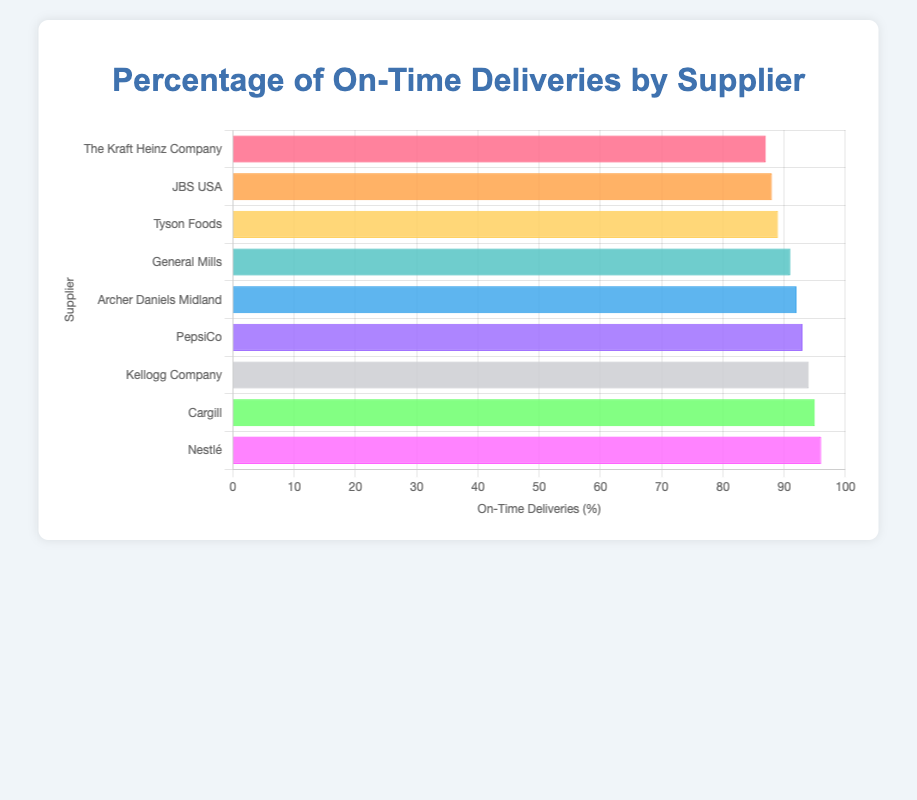What is the percentage of on-time deliveries for the supplier with the best performance? The supplier with the best performance is the one with the highest bar in the chart, which is Nestlé. The percentage of on-time deliveries for Nestlé is shown as 96%.
Answer: 96% Which supplier has the lowest percentage of on-time deliveries? To find the supplier with the lowest percentage of on-time deliveries, look for the shortest bar in the chart. The chart shows that The Kraft Heinz Company has the shortest bar, corresponding to 87%.
Answer: The Kraft Heinz Company What's the difference between the best and worst performers in on-time deliveries? The best performer is Nestlé with 96%, and the worst performer is The Kraft Heinz Company with 87%. The difference between them is 96% - 87% = 9%.
Answer: 9% Are there any suppliers with on-time delivery percentages that are the same? By examining the chart, you can see that each supplier has a distinct percentage of on-time deliveries, with no two suppliers sharing the same value.
Answer: No What is the average percentage of on-time deliveries across all suppliers? To find the average percentage: (95 + 92 + 89 + 96 + 88 + 94 + 93 + 91 + 87) / 9 = 825 / 9 ≈ 91.67%.
Answer: 91.67% Which suppliers have an on-time delivery percentage above 90%? To find this, identify the suppliers with bars extending past the 90% mark. The suppliers are Nestlé, Cargill, Kellogg Company, PepsiCo, Archer Daniels Midland, and General Mills.
Answer: Nestlé, Cargill, Kellogg Company, PepsiCo, Archer Daniels Midland, General Mills How many suppliers have on-time delivery percentages below the average? First, calculate the average percentage as approximately 91.67%. Suppliers with percentages below this are Tyson Foods (89%), JBS USA (88%), and The Kraft Heinz Company (87%). So, there are three suppliers below the average.
Answer: 3 Which supplier's bar is four places below Nestlé's when sorted by on-time delivery percentage? Nestlé has the highest percentage. Counting four positions down from Nestlé (96%) in the bar chart, we land on General Mills (91%).
Answer: General Mills 